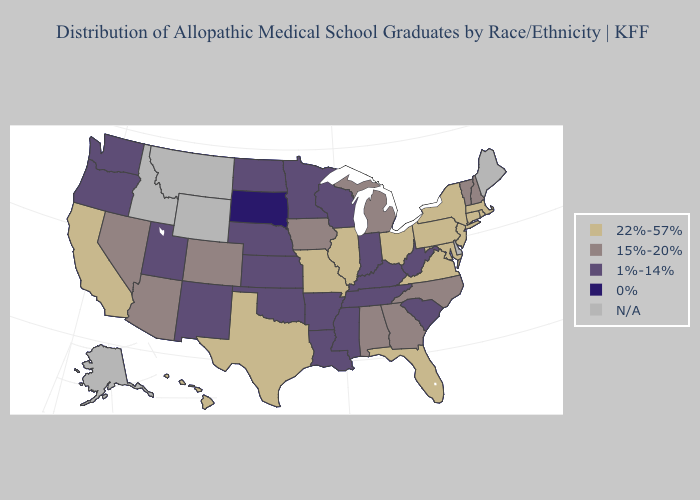What is the highest value in the South ?
Write a very short answer. 22%-57%. Among the states that border Minnesota , which have the lowest value?
Concise answer only. South Dakota. What is the value of California?
Keep it brief. 22%-57%. Does South Dakota have the lowest value in the USA?
Answer briefly. Yes. Name the states that have a value in the range 0%?
Answer briefly. South Dakota. What is the value of Missouri?
Short answer required. 22%-57%. Which states have the lowest value in the South?
Answer briefly. Arkansas, Kentucky, Louisiana, Mississippi, Oklahoma, South Carolina, Tennessee, West Virginia. What is the lowest value in the South?
Give a very brief answer. 1%-14%. Name the states that have a value in the range N/A?
Answer briefly. Alaska, Delaware, Idaho, Maine, Montana, Wyoming. Which states have the lowest value in the West?
Write a very short answer. New Mexico, Oregon, Utah, Washington. What is the highest value in states that border Massachusetts?
Write a very short answer. 22%-57%. What is the value of Connecticut?
Write a very short answer. 22%-57%. Does Maryland have the lowest value in the South?
Write a very short answer. No. 